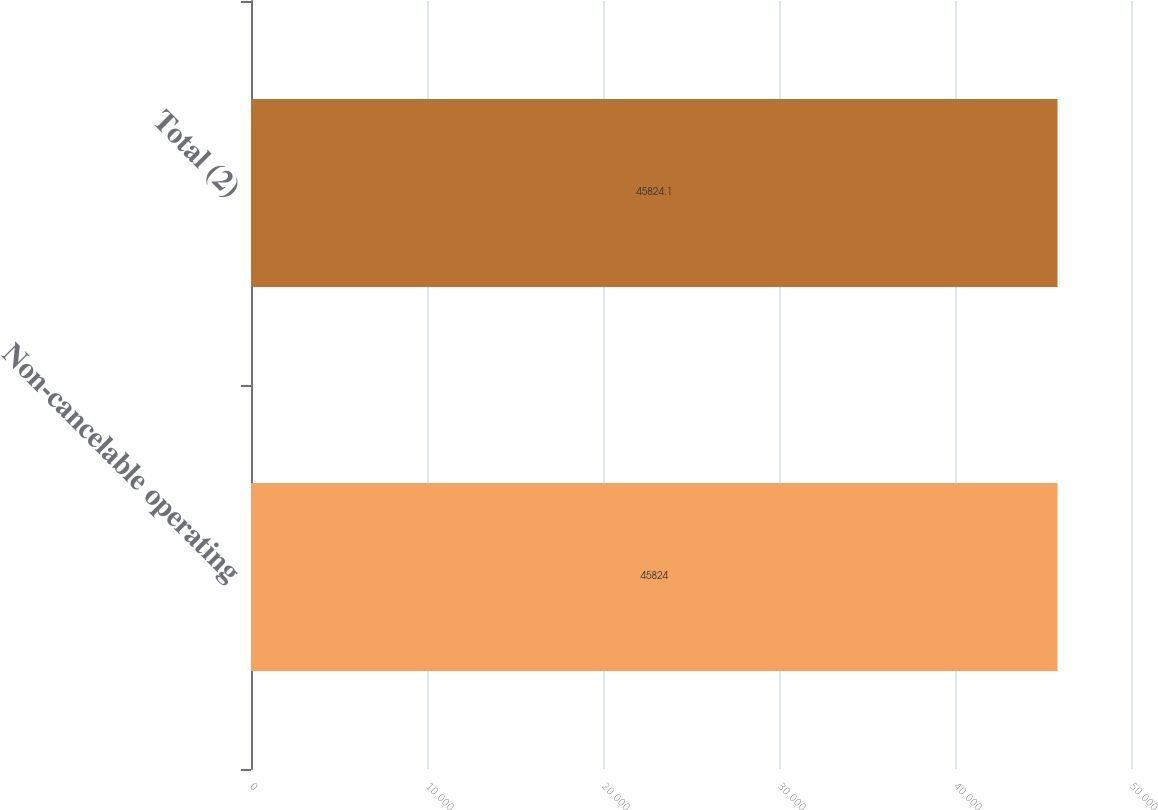Convert chart. <chart><loc_0><loc_0><loc_500><loc_500><bar_chart><fcel>Non-cancelable operating<fcel>Total (2)<nl><fcel>45824<fcel>45824.1<nl></chart> 